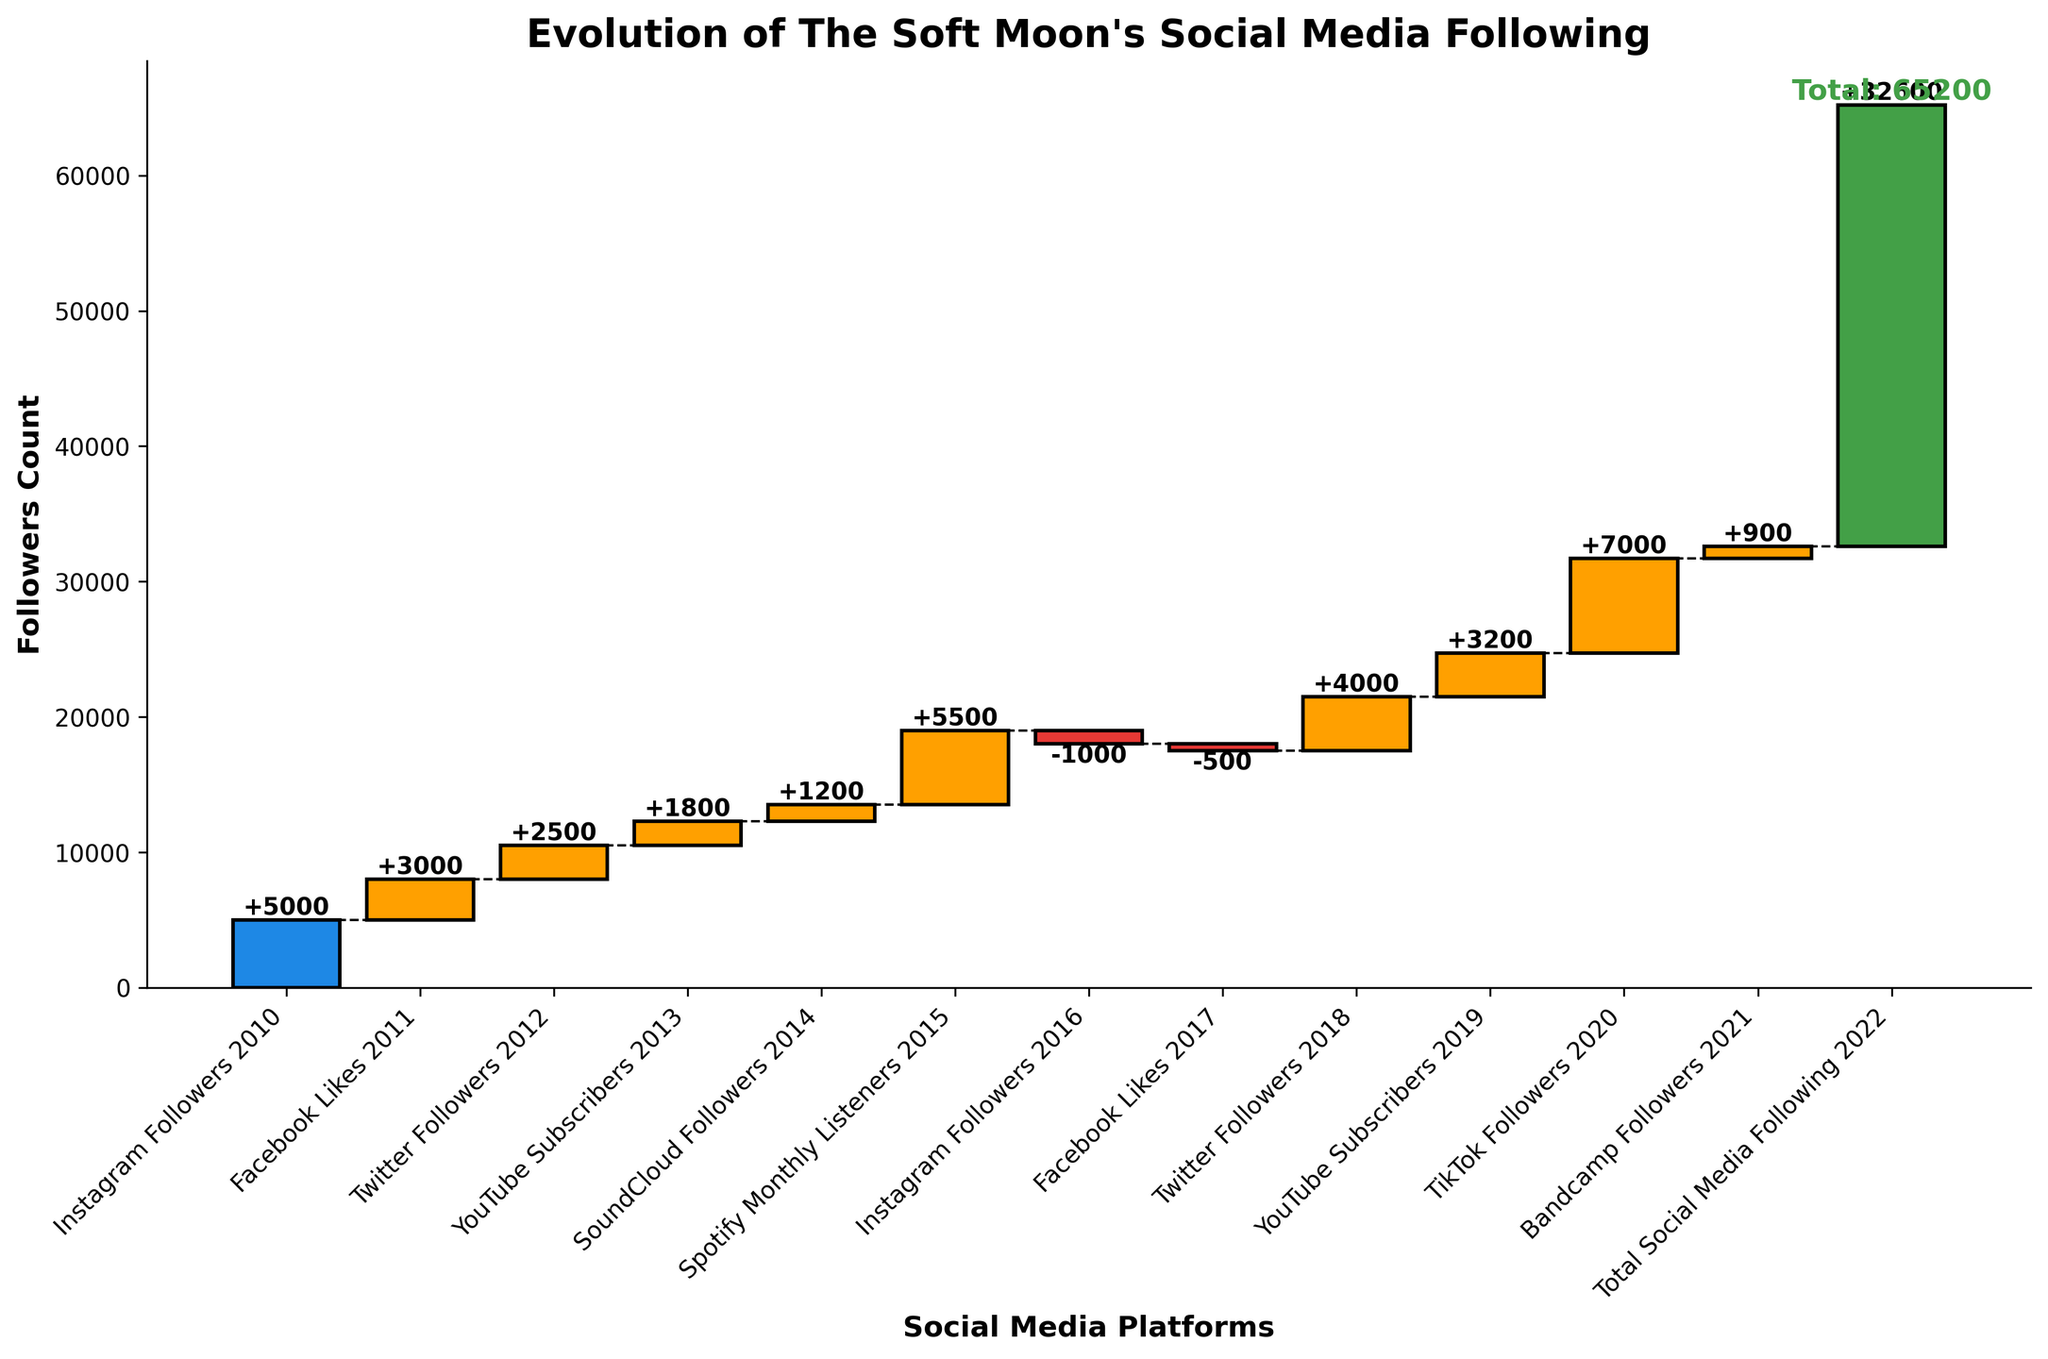What is the initial follower count on Instagram in 2010? The initial follower count is indicated at the beginning of the chart. For Instagram Followers in 2010, the bar starts at 5,000.
Answer: 5,000 Which platform saw the biggest increase in followers? To determine the biggest increase, look for the tallest yellow bar which indicates a positive increase. TikTok Followers in 2020 shows the highest bar with an increase of 7,000.
Answer: TikTok What was the total increase in followers from Facebook Likes in 2011 to Spotify Monthly Listeners in 2015? Sum the increases for each platform from Facebook Likes in 2011 to Spotify Monthly Listeners in 2015: 3,000 + 2,500 + 1,800 + 1,200 + 5,500 = 14,000
Answer: 14,000 Which platforms had a decrease in follower count? Identify the red bars in the chart representing decreases. Instagram Followers in 2016 and Facebook Likes in 2017 show decreases of -1,000 and -500 respectively.
Answer: Instagram and Facebook What is the total social media following in 2022? The final bar, representing all platforms combined up to 2022, shows the cumulative follower count. The number is 32,600.
Answer: 32,600 How many platforms saw an increase in followers by 2021? Count the number of platforms with yellow bars (indicating increases). From 2011 to 2021, there are 8: Facebook, Twitter, YouTube, SoundCloud, Spotify, Twitter again, YouTube again, and Bandcamp.
Answer: 8 What is the cumulative follower count after the increase in Spotify Monthly Listeners in 2015? Calculate the sum of cumulative followers up to 2015: 5,000 (initial) + 3,000 + 2,500 + 1,800 + 1,200 + 5,500 = 19,000
Answer: 19,000 Which year saw the smallest increase in followers, and by how much? Identify the smallest increase by looking at the shortest yellow bar. SoundCloud Followers in 2014 had the smallest increase of 1,200.
Answer: SoundCloud, 1,200 What was the combined follower change from 2016 to 2018? Add the changes from 2016 to 2018: -1,000 (Instagram) - 500 (Facebook) + 4,000 (Twitter) = 2,500
Answer: 2,500 What's the net change in follower count from the decrease in Instagram Followers in 2016 and increase in Twitter Followers in 2018? Calculate the net change: -1,000 (Instagram) + 4,000 (Twitter) = 3,000
Answer: 3,000 